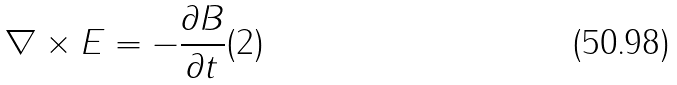Convert formula to latex. <formula><loc_0><loc_0><loc_500><loc_500>\nabla \times E = - \frac { \partial B } { \partial t } ( 2 )</formula> 